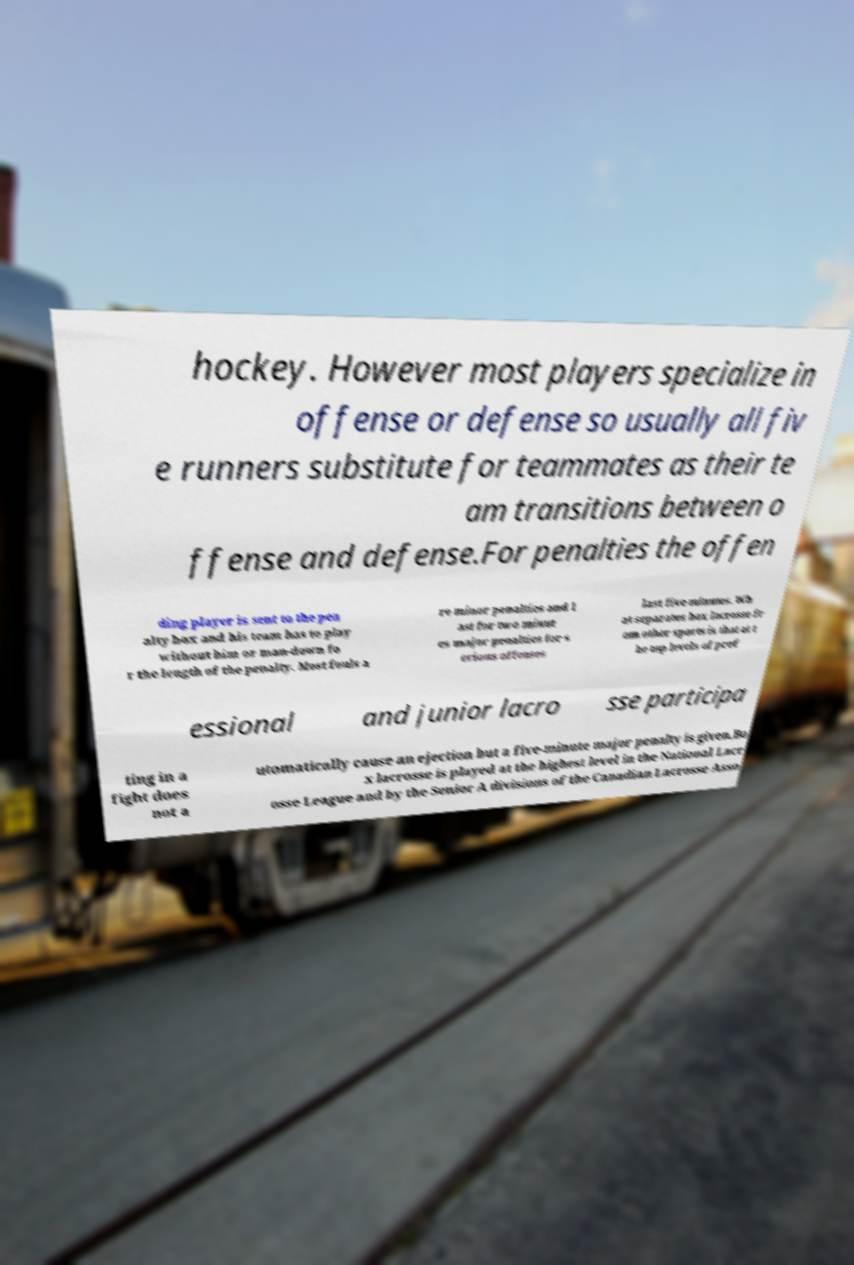Could you assist in decoding the text presented in this image and type it out clearly? hockey. However most players specialize in offense or defense so usually all fiv e runners substitute for teammates as their te am transitions between o ffense and defense.For penalties the offen ding player is sent to the pen alty box and his team has to play without him or man-down fo r the length of the penalty. Most fouls a re minor penalties and l ast for two minut es major penalties for s erious offenses last five minutes. Wh at separates box lacrosse fr om other sports is that at t he top levels of prof essional and junior lacro sse participa ting in a fight does not a utomatically cause an ejection but a five-minute major penalty is given.Bo x lacrosse is played at the highest level in the National Lacr osse League and by the Senior A divisions of the Canadian Lacrosse Asso 